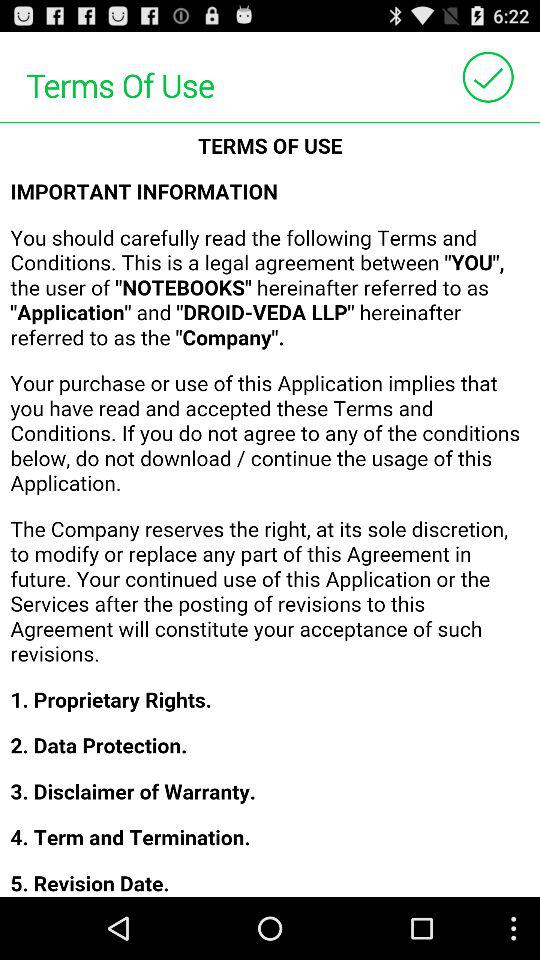How many sections are there in the terms of use?
Answer the question using a single word or phrase. 5 